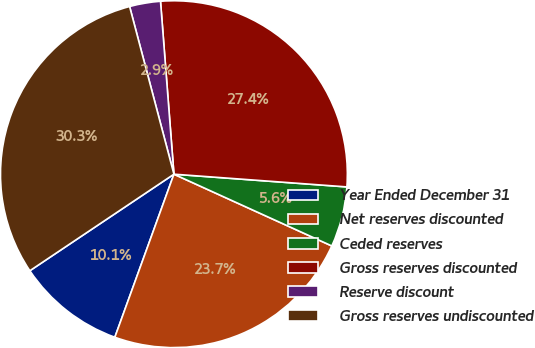<chart> <loc_0><loc_0><loc_500><loc_500><pie_chart><fcel>Year Ended December 31<fcel>Net reserves discounted<fcel>Ceded reserves<fcel>Gross reserves discounted<fcel>Reserve discount<fcel>Gross reserves undiscounted<nl><fcel>10.07%<fcel>23.74%<fcel>5.62%<fcel>27.4%<fcel>2.88%<fcel>30.28%<nl></chart> 